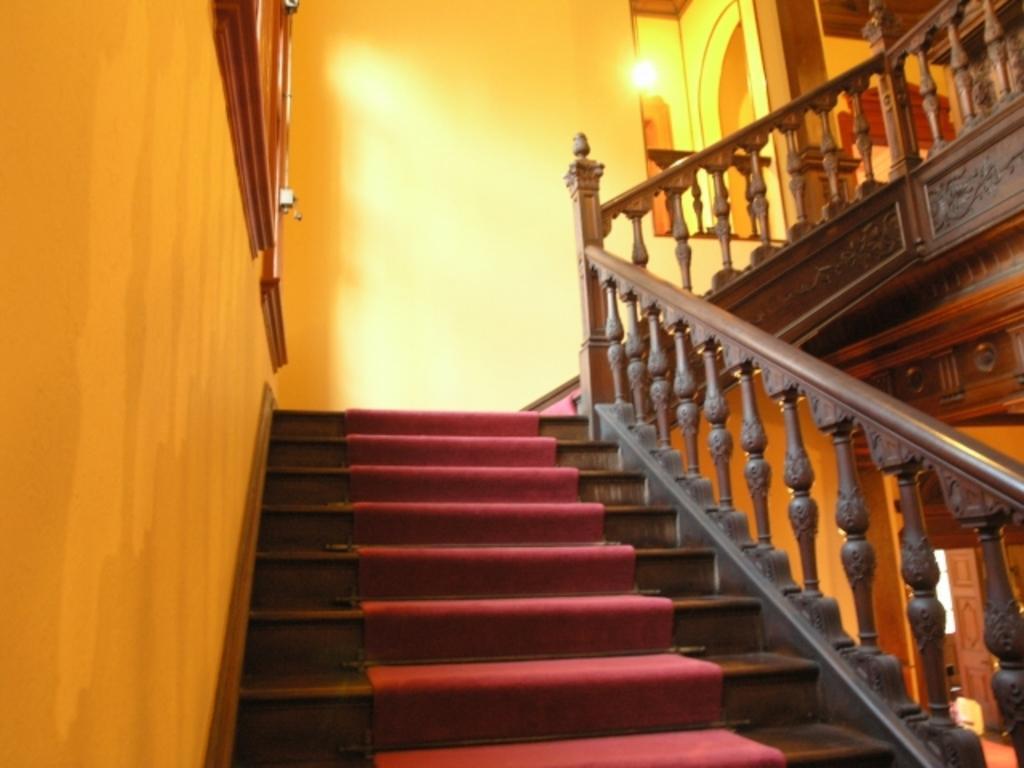Can you describe this image briefly? This image is taken from inside. In this image we can see the stairs of a building. On the stairs there is a red carpet. In the background there is a wall and on the left side of the image there is a window. 